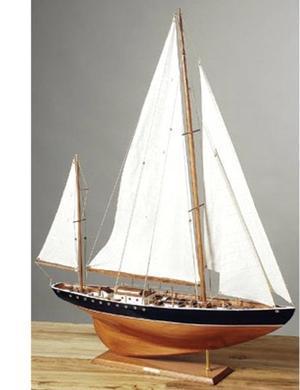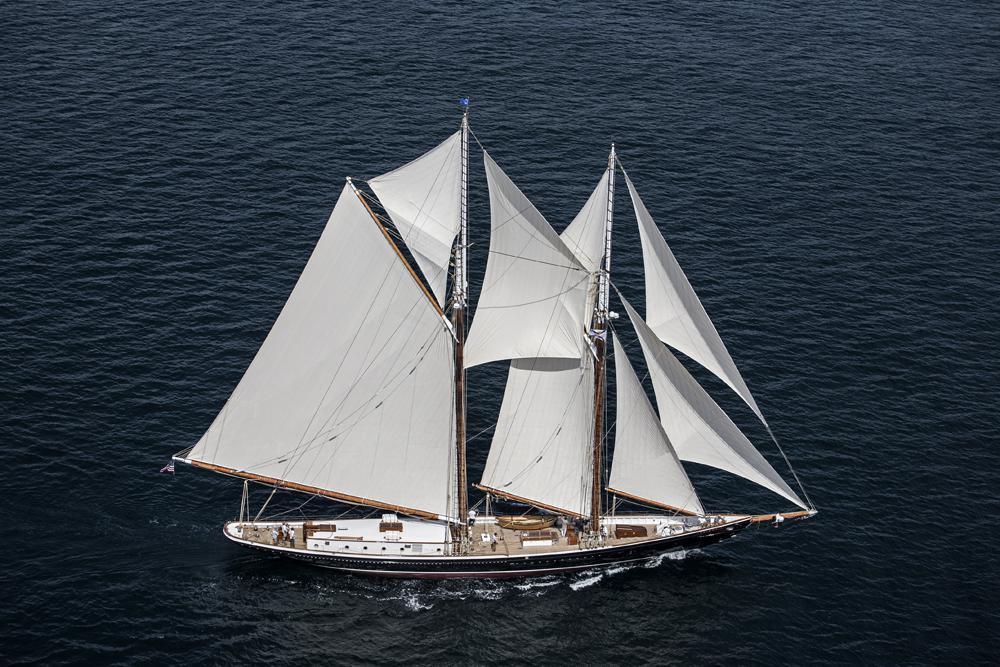The first image is the image on the left, the second image is the image on the right. Considering the images on both sides, is "All sailing ships are floating on water." valid? Answer yes or no. No. The first image is the image on the left, the second image is the image on the right. Analyze the images presented: Is the assertion "The boats in the image on the left are in the water." valid? Answer yes or no. No. 